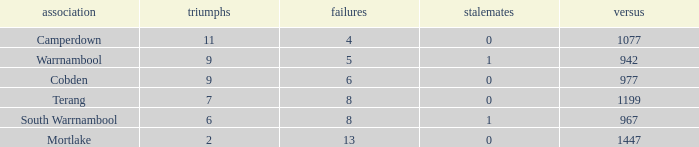What's the number of losses when the wins were more than 11 and had 0 draws? 0.0. 